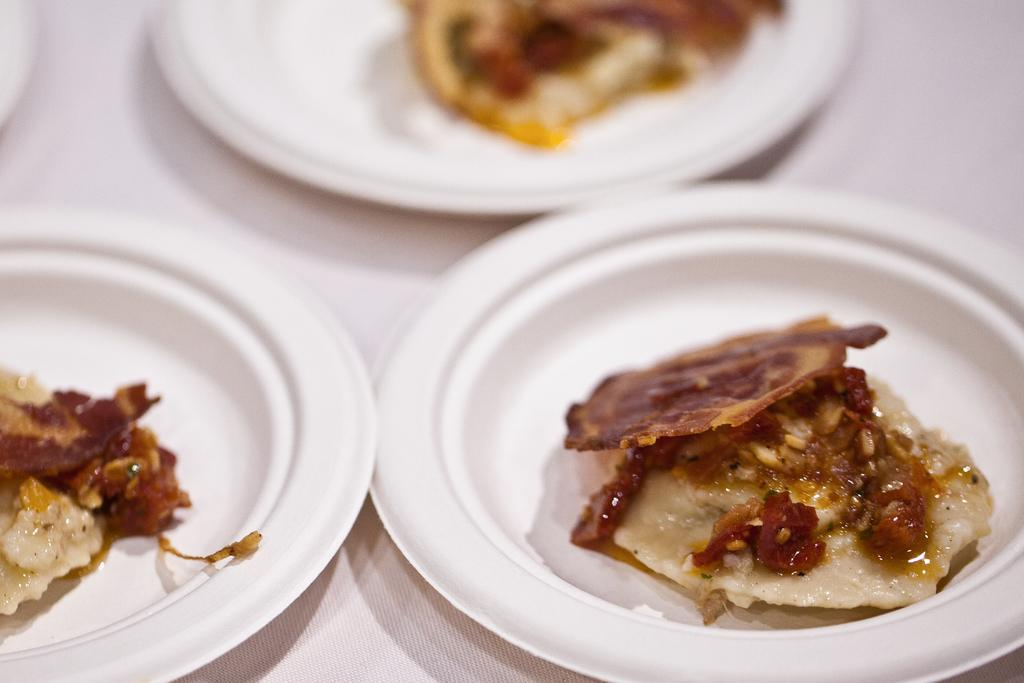How many plates are visible in the image? There are three plates in the image. What are the plates placed on? The plates are on an object. What can be found on the plates? There are food items on the plates. What journey does the idea take in the image? There is no mention of a journey or an idea in the image; it only features three plates with food items on them. 